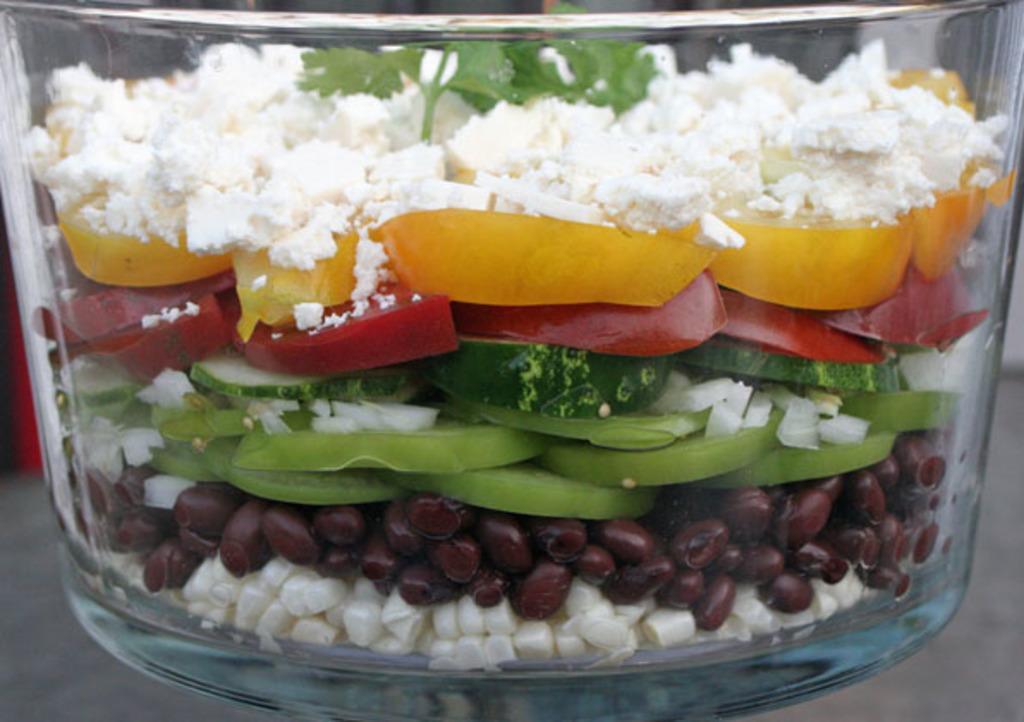Describe this image in one or two sentences. In this image I can see a glass container and food is inside it. Food is in white,green,yellow,red and brown color. 